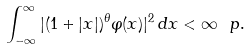<formula> <loc_0><loc_0><loc_500><loc_500>\int _ { - \infty } ^ { \infty } | ( 1 + | x | ) ^ { \theta } \varphi ( x ) | ^ { 2 } \, d x < \infty \ p .</formula> 